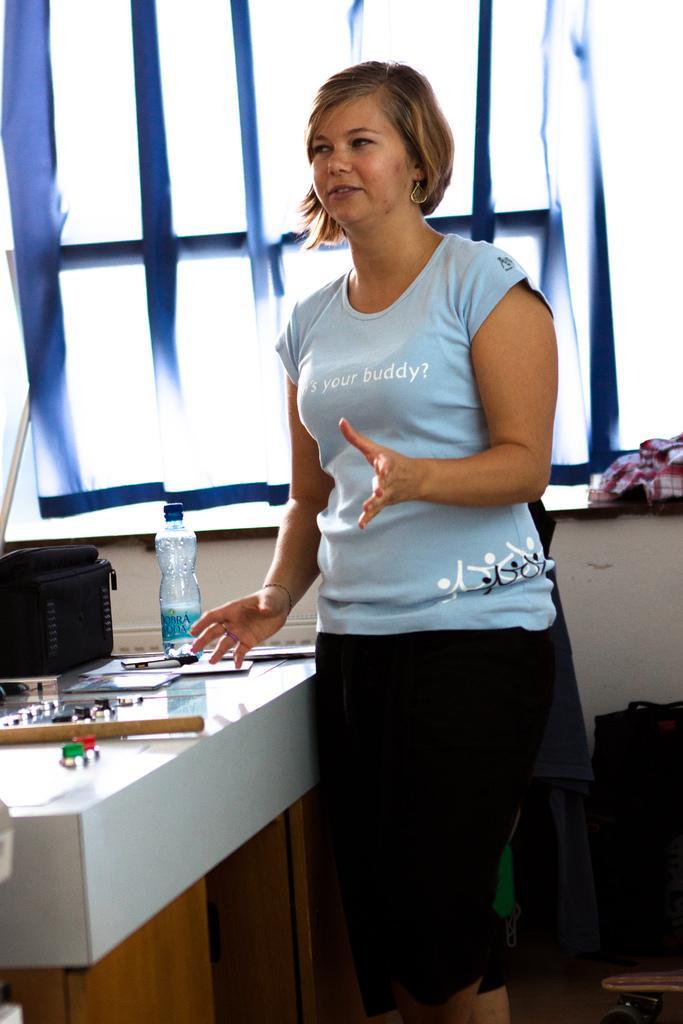Describe this image in one or two sentences. In this picture there is a woman standing and talking and we can see bottle, wooden stick and objects on the table, behind her we can see cloth on the platform and bag on the floor. In the background of the image we can see curtain and window. 